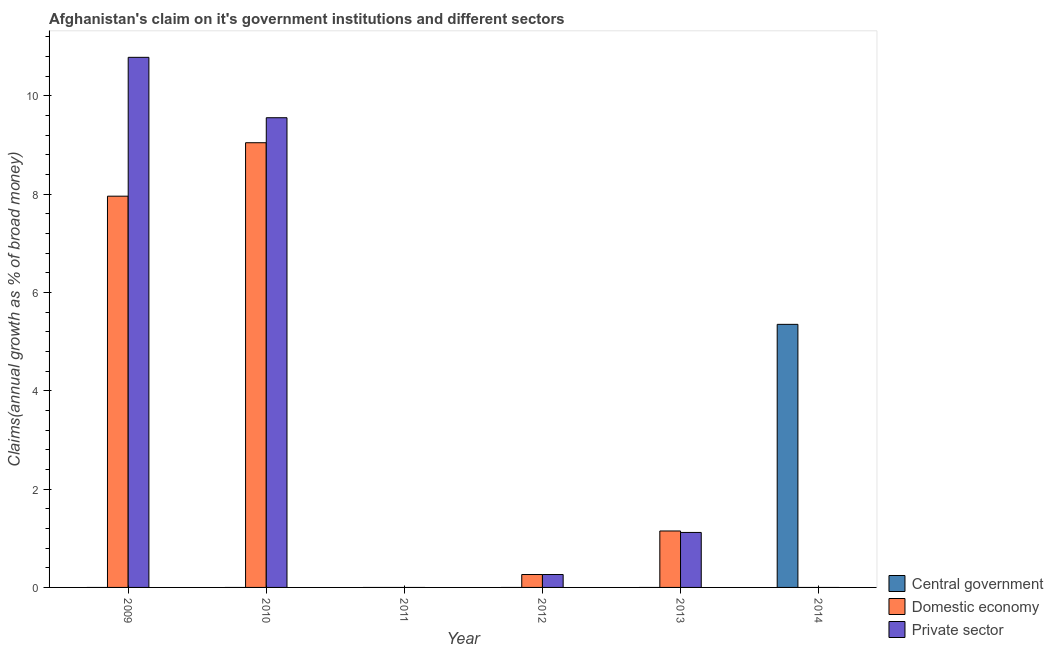Are the number of bars on each tick of the X-axis equal?
Make the answer very short. No. How many bars are there on the 5th tick from the right?
Your answer should be compact. 2. What is the label of the 2nd group of bars from the left?
Your answer should be compact. 2010. What is the percentage of claim on the private sector in 2009?
Your answer should be compact. 10.78. Across all years, what is the maximum percentage of claim on the domestic economy?
Your response must be concise. 9.04. Across all years, what is the minimum percentage of claim on the central government?
Provide a succinct answer. 0. What is the total percentage of claim on the private sector in the graph?
Give a very brief answer. 21.72. What is the difference between the percentage of claim on the private sector in 2009 and that in 2013?
Make the answer very short. 9.66. What is the difference between the percentage of claim on the central government in 2010 and the percentage of claim on the domestic economy in 2012?
Offer a very short reply. 0. What is the average percentage of claim on the domestic economy per year?
Provide a short and direct response. 3.07. In the year 2014, what is the difference between the percentage of claim on the central government and percentage of claim on the domestic economy?
Offer a terse response. 0. What is the ratio of the percentage of claim on the private sector in 2009 to that in 2012?
Give a very brief answer. 41.1. Is the difference between the percentage of claim on the private sector in 2010 and 2013 greater than the difference between the percentage of claim on the central government in 2010 and 2013?
Make the answer very short. No. What is the difference between the highest and the second highest percentage of claim on the domestic economy?
Offer a terse response. 1.09. What is the difference between the highest and the lowest percentage of claim on the domestic economy?
Offer a very short reply. 9.04. Is it the case that in every year, the sum of the percentage of claim on the central government and percentage of claim on the domestic economy is greater than the percentage of claim on the private sector?
Provide a succinct answer. No. Are all the bars in the graph horizontal?
Make the answer very short. No. What is the difference between two consecutive major ticks on the Y-axis?
Provide a succinct answer. 2. Are the values on the major ticks of Y-axis written in scientific E-notation?
Provide a succinct answer. No. Where does the legend appear in the graph?
Give a very brief answer. Bottom right. What is the title of the graph?
Keep it short and to the point. Afghanistan's claim on it's government institutions and different sectors. What is the label or title of the X-axis?
Your answer should be very brief. Year. What is the label or title of the Y-axis?
Offer a very short reply. Claims(annual growth as % of broad money). What is the Claims(annual growth as % of broad money) in Domestic economy in 2009?
Provide a succinct answer. 7.96. What is the Claims(annual growth as % of broad money) in Private sector in 2009?
Your answer should be compact. 10.78. What is the Claims(annual growth as % of broad money) in Domestic economy in 2010?
Give a very brief answer. 9.04. What is the Claims(annual growth as % of broad money) in Private sector in 2010?
Ensure brevity in your answer.  9.55. What is the Claims(annual growth as % of broad money) of Domestic economy in 2011?
Offer a very short reply. 0. What is the Claims(annual growth as % of broad money) in Central government in 2012?
Keep it short and to the point. 0. What is the Claims(annual growth as % of broad money) of Domestic economy in 2012?
Offer a terse response. 0.26. What is the Claims(annual growth as % of broad money) of Private sector in 2012?
Your answer should be very brief. 0.26. What is the Claims(annual growth as % of broad money) in Central government in 2013?
Your answer should be very brief. 0. What is the Claims(annual growth as % of broad money) in Domestic economy in 2013?
Provide a succinct answer. 1.15. What is the Claims(annual growth as % of broad money) of Private sector in 2013?
Give a very brief answer. 1.12. What is the Claims(annual growth as % of broad money) in Central government in 2014?
Make the answer very short. 5.35. Across all years, what is the maximum Claims(annual growth as % of broad money) of Central government?
Keep it short and to the point. 5.35. Across all years, what is the maximum Claims(annual growth as % of broad money) in Domestic economy?
Provide a succinct answer. 9.04. Across all years, what is the maximum Claims(annual growth as % of broad money) in Private sector?
Offer a terse response. 10.78. Across all years, what is the minimum Claims(annual growth as % of broad money) of Domestic economy?
Make the answer very short. 0. Across all years, what is the minimum Claims(annual growth as % of broad money) in Private sector?
Give a very brief answer. 0. What is the total Claims(annual growth as % of broad money) of Central government in the graph?
Offer a very short reply. 5.35. What is the total Claims(annual growth as % of broad money) of Domestic economy in the graph?
Provide a short and direct response. 18.41. What is the total Claims(annual growth as % of broad money) in Private sector in the graph?
Your answer should be compact. 21.72. What is the difference between the Claims(annual growth as % of broad money) of Domestic economy in 2009 and that in 2010?
Your answer should be very brief. -1.09. What is the difference between the Claims(annual growth as % of broad money) of Private sector in 2009 and that in 2010?
Provide a succinct answer. 1.23. What is the difference between the Claims(annual growth as % of broad money) of Domestic economy in 2009 and that in 2012?
Your answer should be compact. 7.7. What is the difference between the Claims(annual growth as % of broad money) in Private sector in 2009 and that in 2012?
Provide a succinct answer. 10.52. What is the difference between the Claims(annual growth as % of broad money) of Domestic economy in 2009 and that in 2013?
Your answer should be compact. 6.81. What is the difference between the Claims(annual growth as % of broad money) in Private sector in 2009 and that in 2013?
Your answer should be very brief. 9.66. What is the difference between the Claims(annual growth as % of broad money) of Domestic economy in 2010 and that in 2012?
Your answer should be compact. 8.78. What is the difference between the Claims(annual growth as % of broad money) in Private sector in 2010 and that in 2012?
Give a very brief answer. 9.29. What is the difference between the Claims(annual growth as % of broad money) of Domestic economy in 2010 and that in 2013?
Give a very brief answer. 7.9. What is the difference between the Claims(annual growth as % of broad money) in Private sector in 2010 and that in 2013?
Your answer should be compact. 8.43. What is the difference between the Claims(annual growth as % of broad money) in Domestic economy in 2012 and that in 2013?
Make the answer very short. -0.89. What is the difference between the Claims(annual growth as % of broad money) of Private sector in 2012 and that in 2013?
Your response must be concise. -0.86. What is the difference between the Claims(annual growth as % of broad money) of Domestic economy in 2009 and the Claims(annual growth as % of broad money) of Private sector in 2010?
Your answer should be compact. -1.6. What is the difference between the Claims(annual growth as % of broad money) in Domestic economy in 2009 and the Claims(annual growth as % of broad money) in Private sector in 2012?
Offer a very short reply. 7.7. What is the difference between the Claims(annual growth as % of broad money) in Domestic economy in 2009 and the Claims(annual growth as % of broad money) in Private sector in 2013?
Offer a very short reply. 6.84. What is the difference between the Claims(annual growth as % of broad money) of Domestic economy in 2010 and the Claims(annual growth as % of broad money) of Private sector in 2012?
Make the answer very short. 8.78. What is the difference between the Claims(annual growth as % of broad money) in Domestic economy in 2010 and the Claims(annual growth as % of broad money) in Private sector in 2013?
Make the answer very short. 7.93. What is the difference between the Claims(annual growth as % of broad money) of Domestic economy in 2012 and the Claims(annual growth as % of broad money) of Private sector in 2013?
Your answer should be very brief. -0.86. What is the average Claims(annual growth as % of broad money) of Central government per year?
Keep it short and to the point. 0.89. What is the average Claims(annual growth as % of broad money) in Domestic economy per year?
Provide a short and direct response. 3.07. What is the average Claims(annual growth as % of broad money) in Private sector per year?
Make the answer very short. 3.62. In the year 2009, what is the difference between the Claims(annual growth as % of broad money) of Domestic economy and Claims(annual growth as % of broad money) of Private sector?
Offer a very short reply. -2.82. In the year 2010, what is the difference between the Claims(annual growth as % of broad money) in Domestic economy and Claims(annual growth as % of broad money) in Private sector?
Your response must be concise. -0.51. In the year 2013, what is the difference between the Claims(annual growth as % of broad money) of Domestic economy and Claims(annual growth as % of broad money) of Private sector?
Give a very brief answer. 0.03. What is the ratio of the Claims(annual growth as % of broad money) in Domestic economy in 2009 to that in 2010?
Ensure brevity in your answer.  0.88. What is the ratio of the Claims(annual growth as % of broad money) in Private sector in 2009 to that in 2010?
Your answer should be very brief. 1.13. What is the ratio of the Claims(annual growth as % of broad money) of Domestic economy in 2009 to that in 2012?
Provide a succinct answer. 30.34. What is the ratio of the Claims(annual growth as % of broad money) of Private sector in 2009 to that in 2012?
Your answer should be very brief. 41.1. What is the ratio of the Claims(annual growth as % of broad money) of Domestic economy in 2009 to that in 2013?
Ensure brevity in your answer.  6.93. What is the ratio of the Claims(annual growth as % of broad money) in Private sector in 2009 to that in 2013?
Keep it short and to the point. 9.64. What is the ratio of the Claims(annual growth as % of broad money) of Domestic economy in 2010 to that in 2012?
Provide a short and direct response. 34.48. What is the ratio of the Claims(annual growth as % of broad money) in Private sector in 2010 to that in 2012?
Ensure brevity in your answer.  36.42. What is the ratio of the Claims(annual growth as % of broad money) of Domestic economy in 2010 to that in 2013?
Ensure brevity in your answer.  7.88. What is the ratio of the Claims(annual growth as % of broad money) of Private sector in 2010 to that in 2013?
Your answer should be compact. 8.54. What is the ratio of the Claims(annual growth as % of broad money) of Domestic economy in 2012 to that in 2013?
Your answer should be very brief. 0.23. What is the ratio of the Claims(annual growth as % of broad money) of Private sector in 2012 to that in 2013?
Offer a very short reply. 0.23. What is the difference between the highest and the second highest Claims(annual growth as % of broad money) in Domestic economy?
Make the answer very short. 1.09. What is the difference between the highest and the second highest Claims(annual growth as % of broad money) in Private sector?
Offer a terse response. 1.23. What is the difference between the highest and the lowest Claims(annual growth as % of broad money) in Central government?
Your answer should be very brief. 5.35. What is the difference between the highest and the lowest Claims(annual growth as % of broad money) in Domestic economy?
Ensure brevity in your answer.  9.04. What is the difference between the highest and the lowest Claims(annual growth as % of broad money) in Private sector?
Your answer should be very brief. 10.78. 